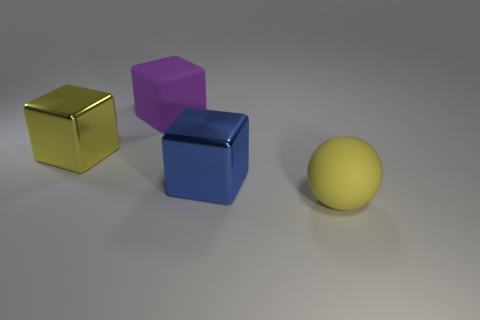Subtract all metal blocks. How many blocks are left? 1 Subtract all blue cubes. How many cubes are left? 2 Add 2 large blue cubes. How many objects exist? 6 Subtract all blocks. How many objects are left? 1 Subtract 1 balls. How many balls are left? 0 Add 3 big yellow metal blocks. How many big yellow metal blocks exist? 4 Subtract 0 gray spheres. How many objects are left? 4 Subtract all purple blocks. Subtract all red cylinders. How many blocks are left? 2 Subtract all gray cylinders. How many cyan balls are left? 0 Subtract all purple objects. Subtract all yellow rubber blocks. How many objects are left? 3 